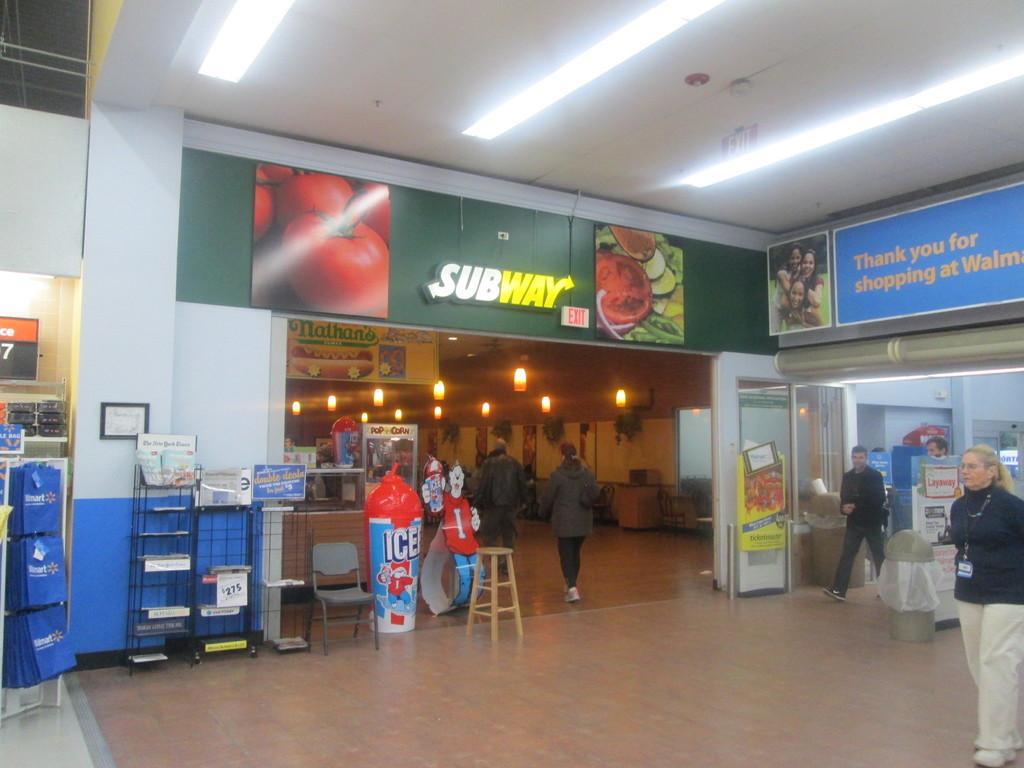In one or two sentences, can you explain what this image depicts? There are some persons, chair, table and other objects are present in the middle of this image. There is a text board and some posters are attached to the wall we can see in the middle of this image, and there are some lights at the top of this image. 